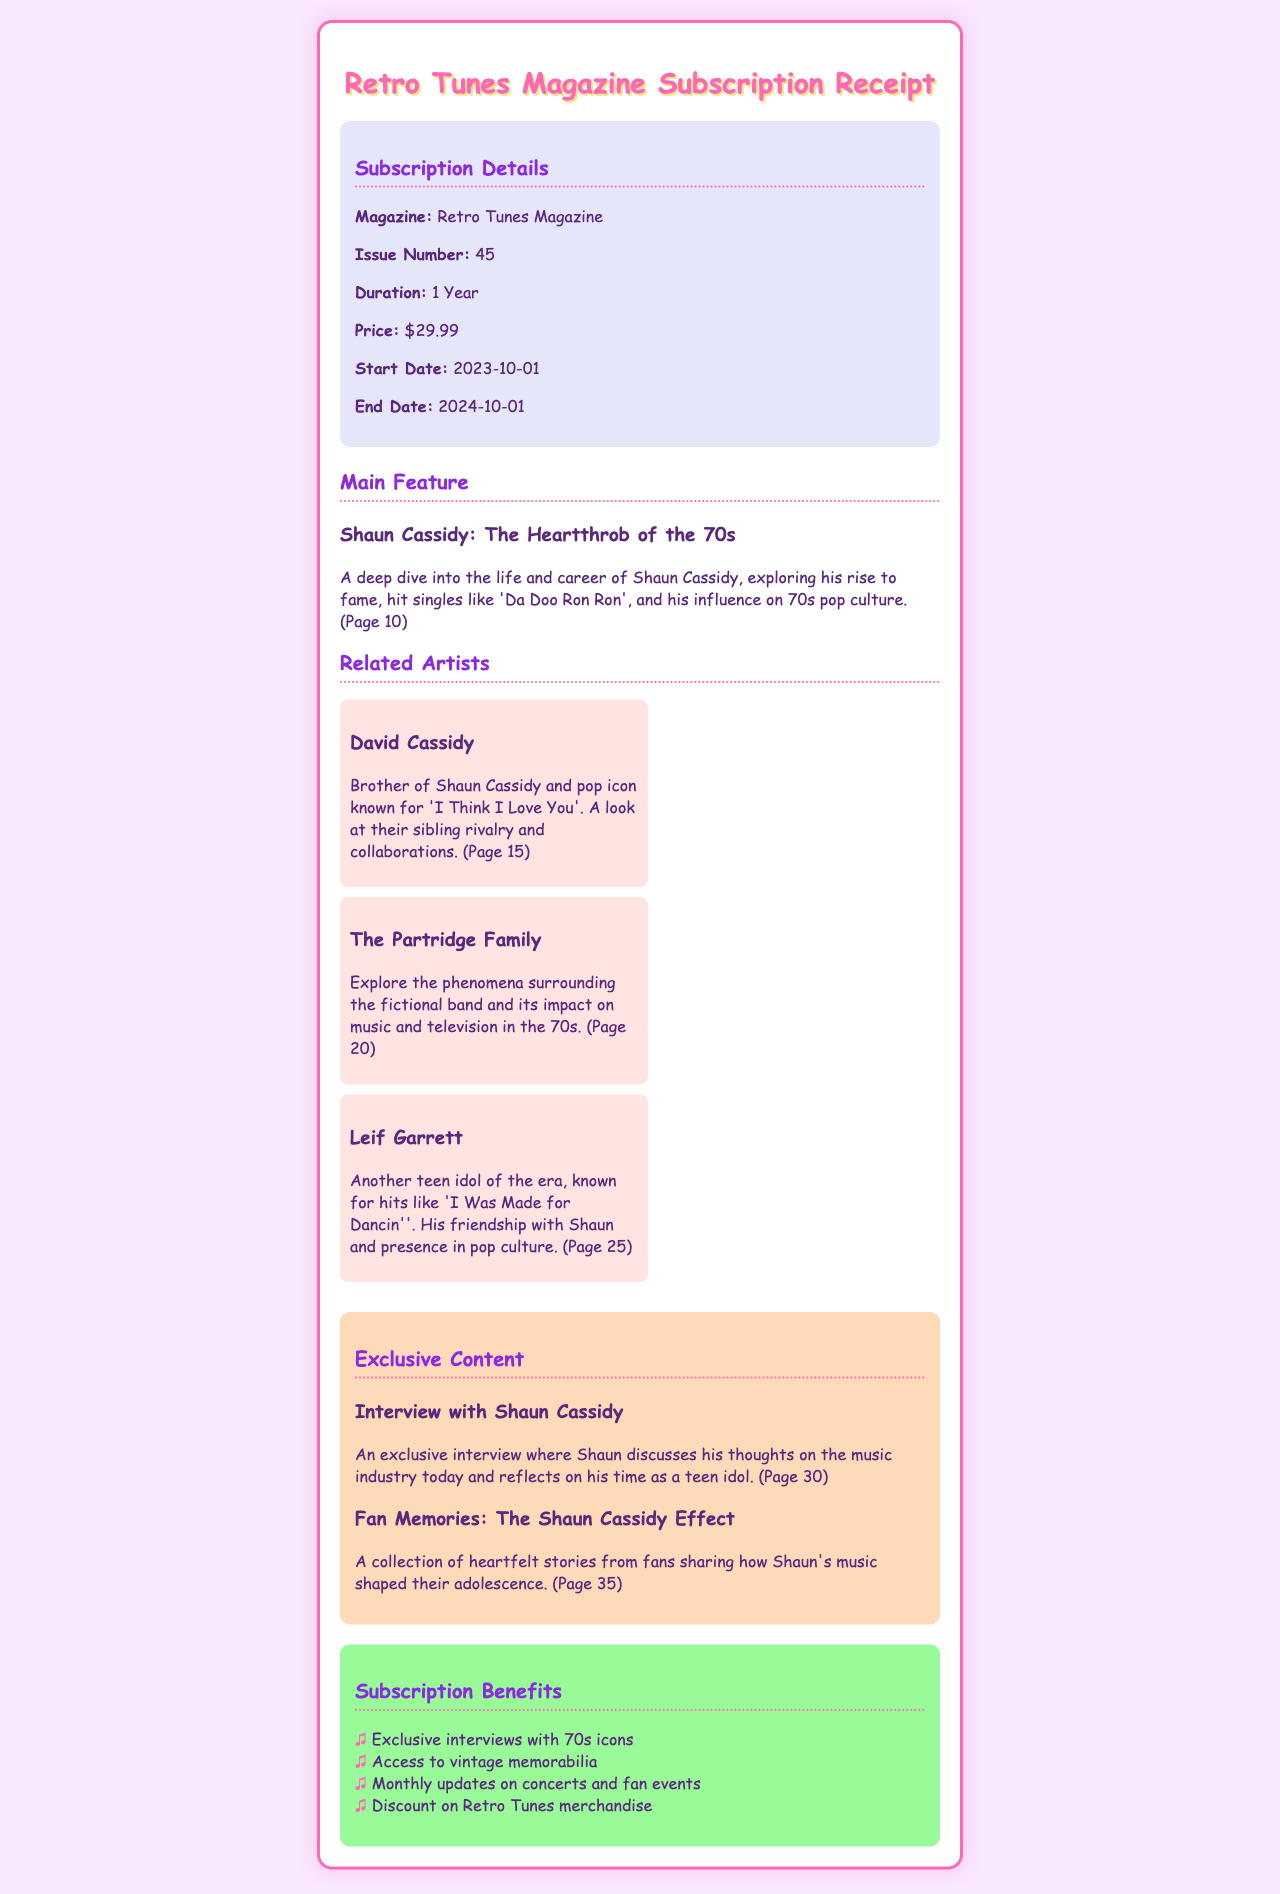What is the magazine's name? The document states the name of the magazine as Retro Tunes Magazine.
Answer: Retro Tunes Magazine What is the price of the subscription? The price listed for the subscription is $29.99.
Answer: $29.99 When does the subscription start? The start date of the subscription is provided in the document as 2023-10-01.
Answer: 2023-10-01 Who is featured in the main article? The main feature highlights Shaun Cassidy, as mentioned in the section title.
Answer: Shaun Cassidy Which page contains the exclusive interview with Shaun Cassidy? The document specifies that the exclusive interview is found on page 30.
Answer: Page 30 What is one of the benefits of the subscription? The benefits section lists multiple advantages, one of which is exclusive interviews with 70s icons.
Answer: Exclusive interviews with 70s icons Which artist is known for 'I Was Made for Dancin''? The document mentions Leif Garrett as the artist known for that song.
Answer: Leif Garrett What is the duration of the subscription? The document indicates that the duration of the subscription is 1 Year.
Answer: 1 Year What is the issue number of the magazine? The issue number is stated in the subscription details as 45.
Answer: 45 